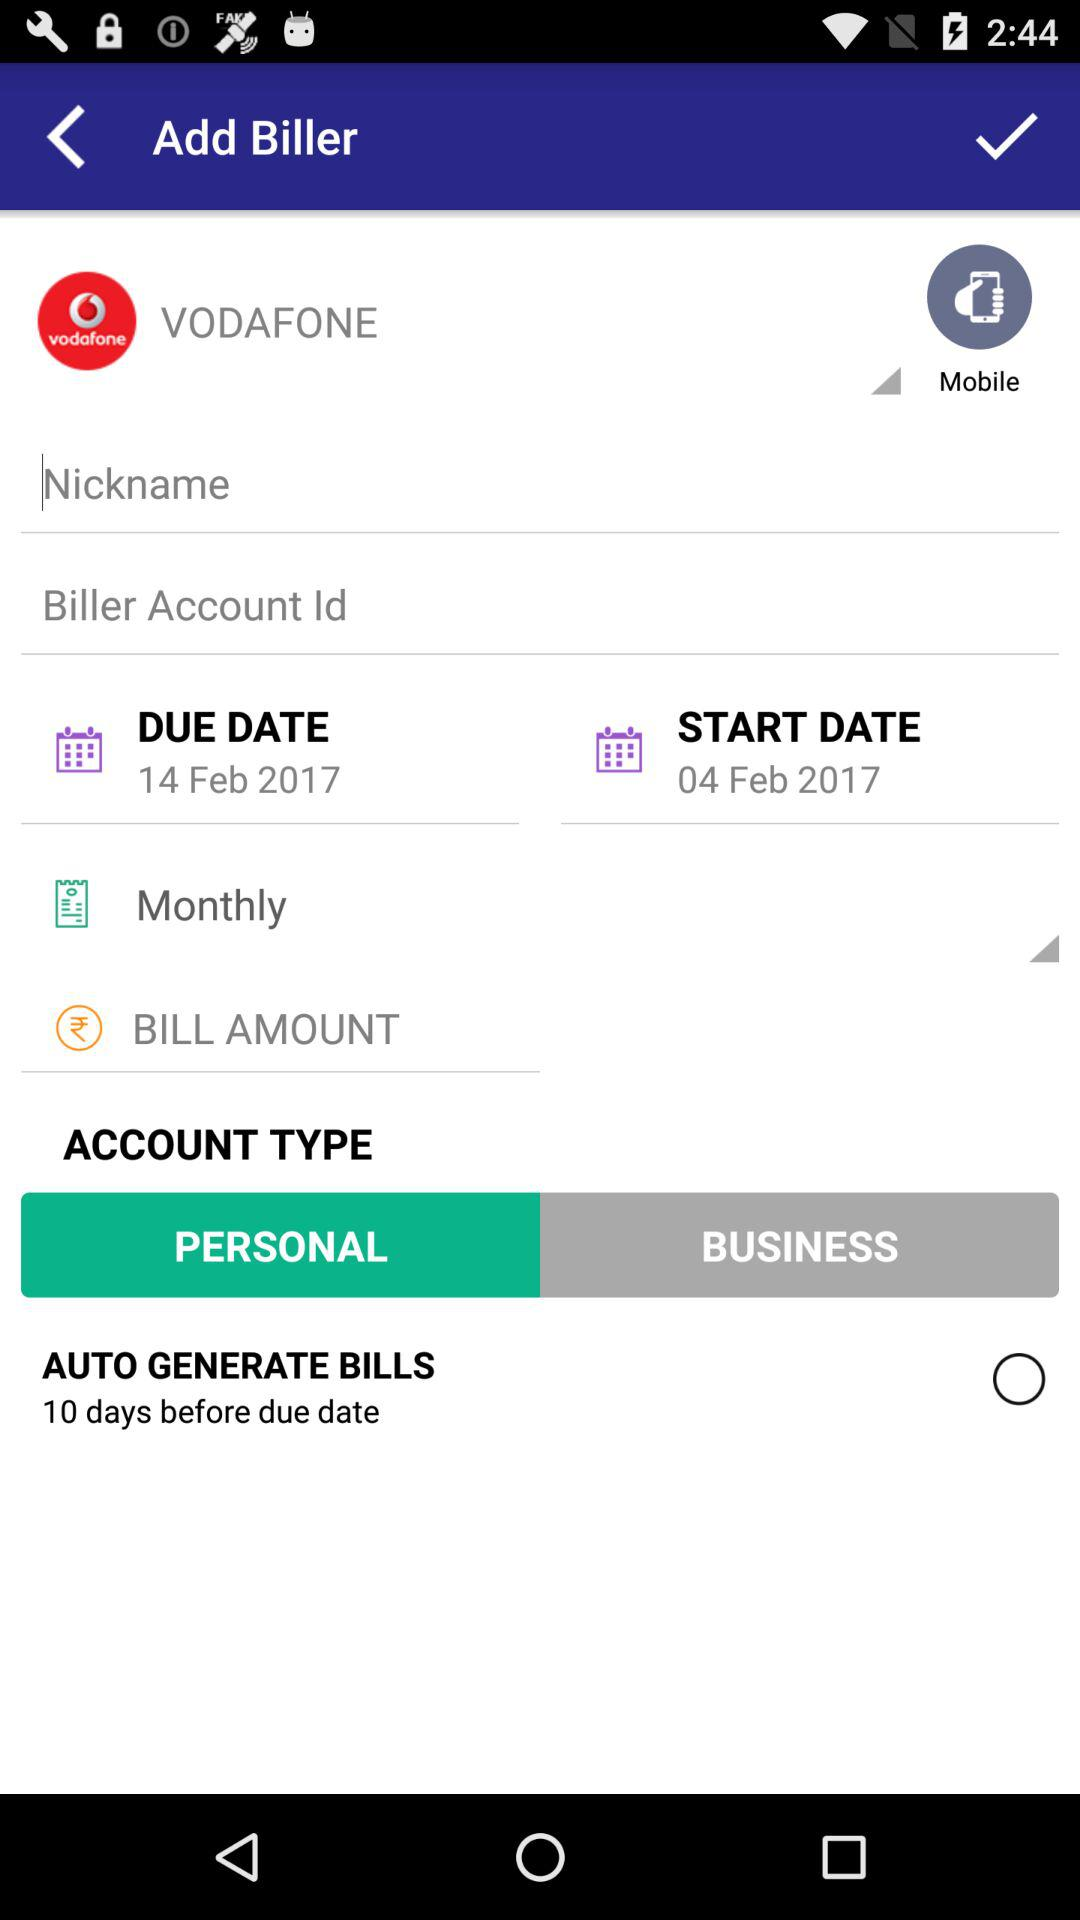What is the due date? The due date is February 14, 2017. 